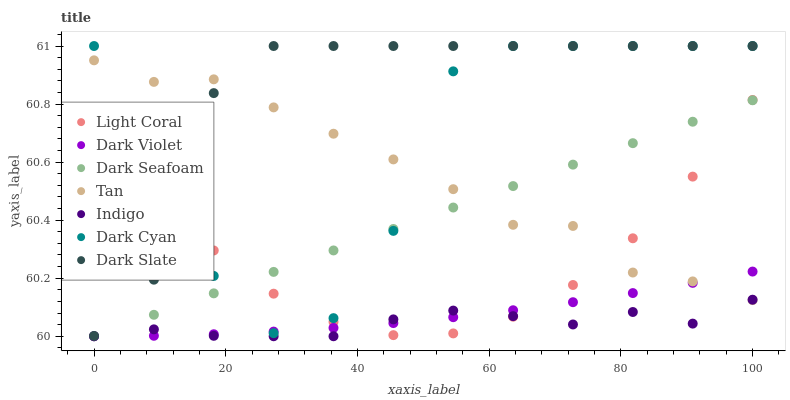Does Indigo have the minimum area under the curve?
Answer yes or no. Yes. Does Dark Slate have the maximum area under the curve?
Answer yes or no. Yes. Does Dark Violet have the minimum area under the curve?
Answer yes or no. No. Does Dark Violet have the maximum area under the curve?
Answer yes or no. No. Is Dark Seafoam the smoothest?
Answer yes or no. Yes. Is Dark Cyan the roughest?
Answer yes or no. Yes. Is Dark Violet the smoothest?
Answer yes or no. No. Is Dark Violet the roughest?
Answer yes or no. No. Does Indigo have the lowest value?
Answer yes or no. Yes. Does Dark Violet have the lowest value?
Answer yes or no. No. Does Dark Cyan have the highest value?
Answer yes or no. Yes. Does Dark Violet have the highest value?
Answer yes or no. No. Is Indigo less than Dark Slate?
Answer yes or no. Yes. Is Dark Slate greater than Dark Seafoam?
Answer yes or no. Yes. Does Tan intersect Dark Slate?
Answer yes or no. Yes. Is Tan less than Dark Slate?
Answer yes or no. No. Is Tan greater than Dark Slate?
Answer yes or no. No. Does Indigo intersect Dark Slate?
Answer yes or no. No. 